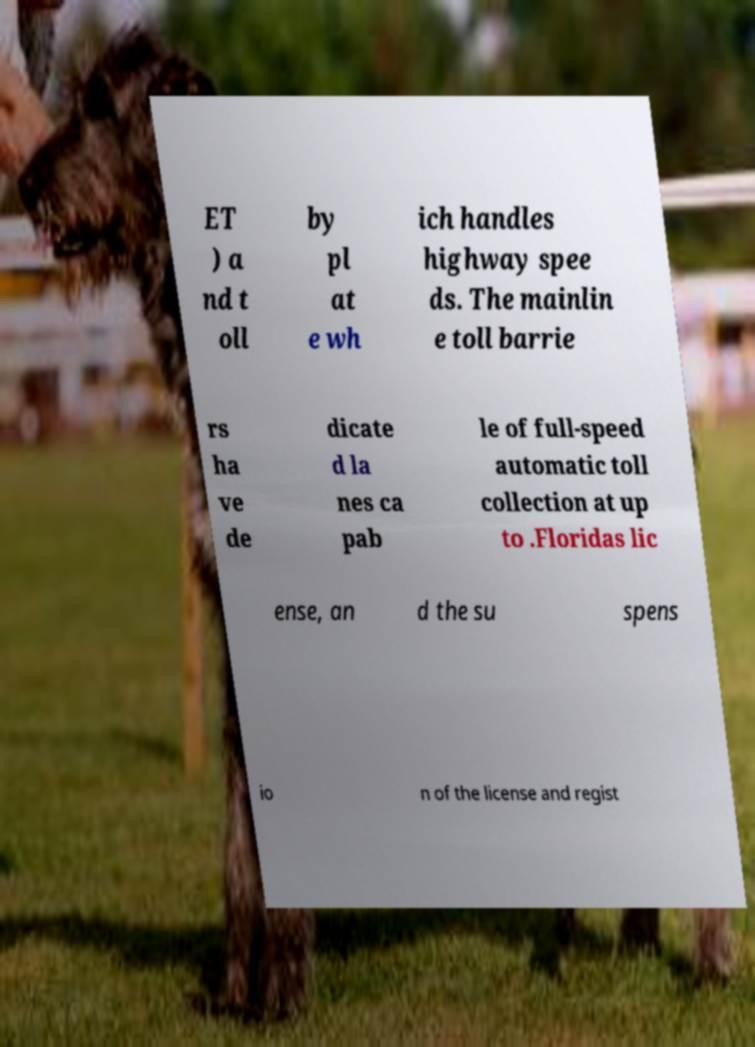Could you assist in decoding the text presented in this image and type it out clearly? ET ) a nd t oll by pl at e wh ich handles highway spee ds. The mainlin e toll barrie rs ha ve de dicate d la nes ca pab le of full-speed automatic toll collection at up to .Floridas lic ense, an d the su spens io n of the license and regist 